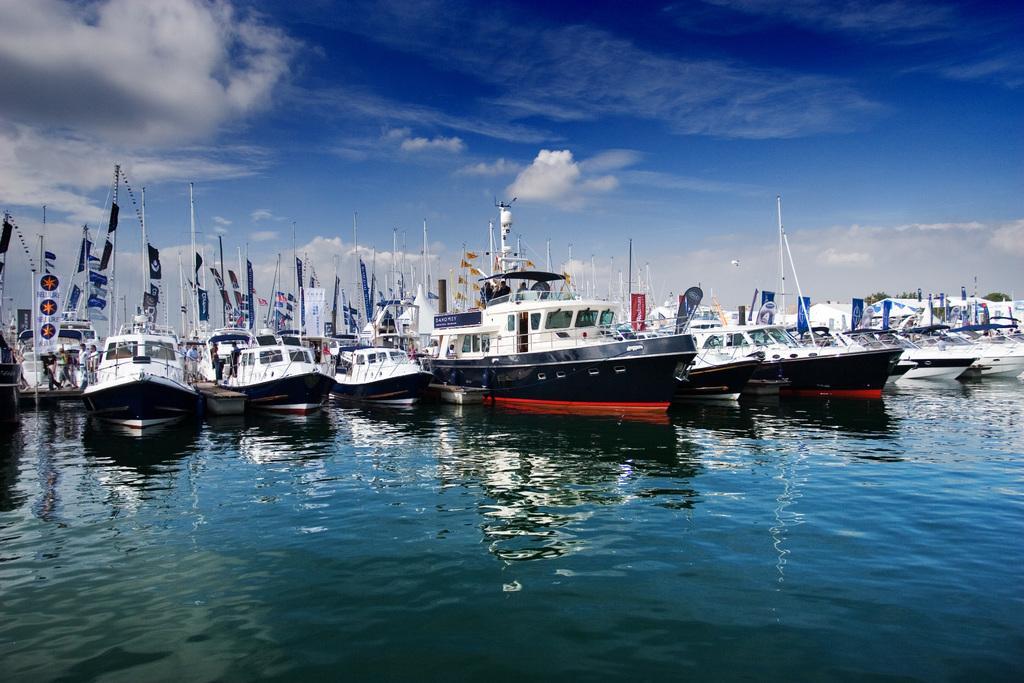Describe this image in one or two sentences. In the picture I can see boats on the water. In the background I can see the sky. 